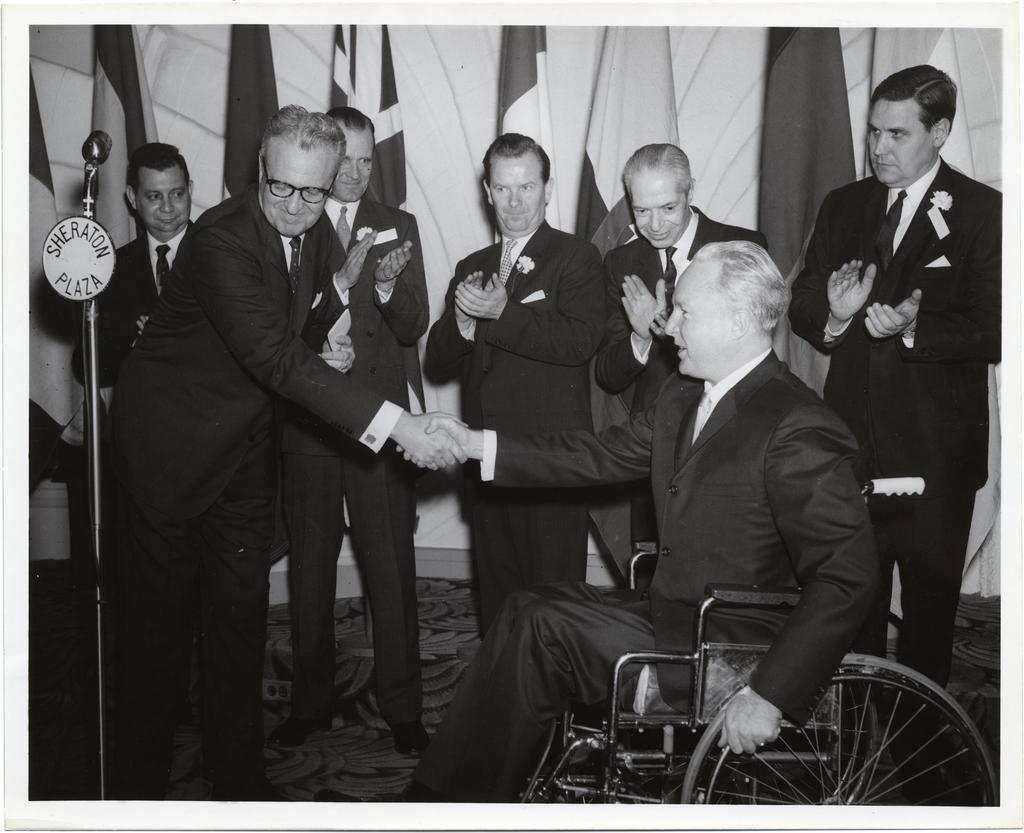Can you describe this image briefly? In the image we can see there are men standing and one is sitting on the wheelchair, they are wearing clothes and shoes. Here we can see the mic to the stand and behind them, we can see the flags. 